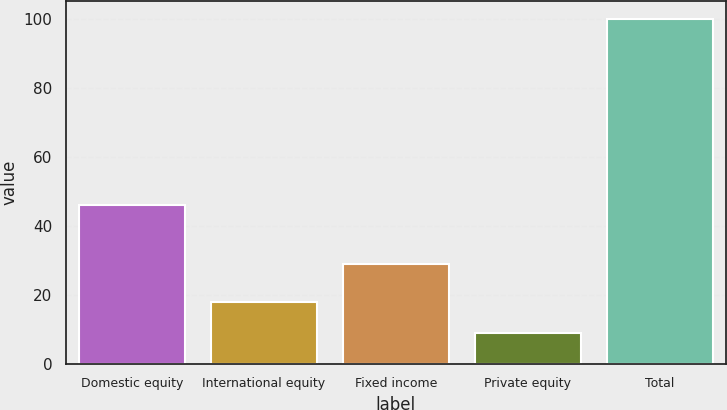Convert chart to OTSL. <chart><loc_0><loc_0><loc_500><loc_500><bar_chart><fcel>Domestic equity<fcel>International equity<fcel>Fixed income<fcel>Private equity<fcel>Total<nl><fcel>46<fcel>18.1<fcel>29<fcel>9<fcel>100<nl></chart> 